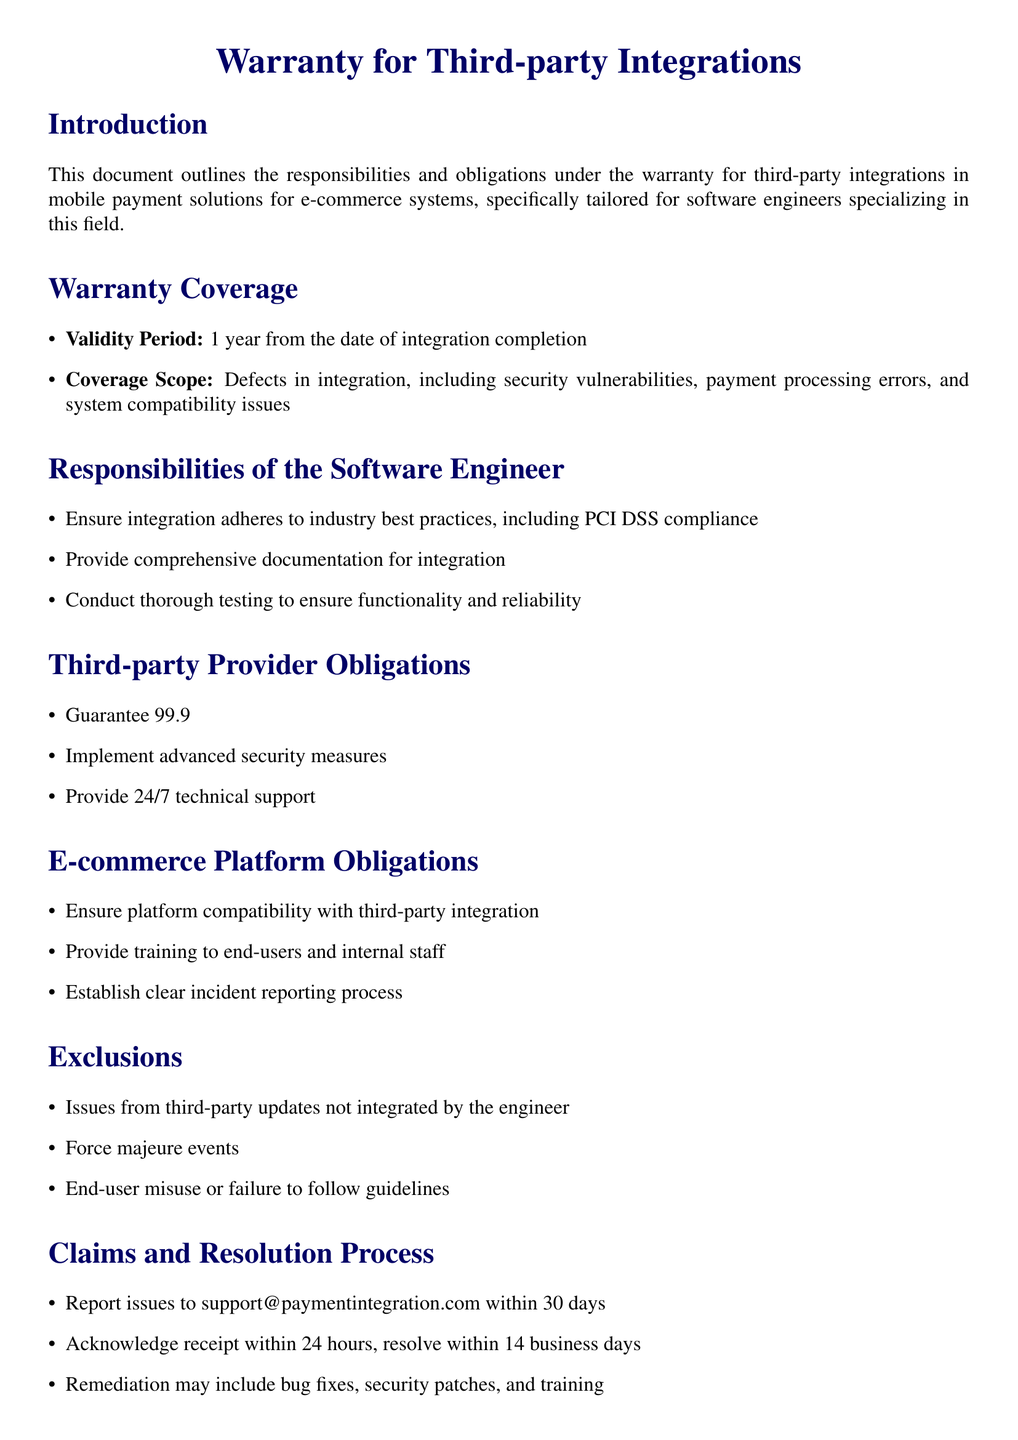What is the validity period of the warranty? The validity period is specified under warranty coverage, stating that it lasts 1 year from the date of integration completion.
Answer: 1 year What is the uptime guarantee provided by third-party providers? The document specifies that third-party providers must guarantee 99.9% uptime for payment processing services.
Answer: 99.9% What types of issues are excluded from warranty coverage? The document lists issues from third-party updates, force majeure events, and end-user misuse as exclusions.
Answer: Third-party updates, force majeure, end-user misuse How long does the support team have to acknowledge an issue report? The claims and resolution process outlines that the support team must acknowledge receipt of the report within 24 hours.
Answer: 24 hours What is the total financial liability cap mentioned in the document? The document states that the total financial liability is capped at fifty thousand dollars.
Answer: $50,000 What is one of the responsibilities of the software engineer? One of the responsibilities includes ensuring that the integration adheres to industry best practices, such as PCI DSS compliance.
Answer: PCI DSS compliance What must e-commerce platforms provide in relation to third-party integration? The document specifies that e-commerce platforms must ensure compatibility with third-party integration.
Answer: Compatibility What is included in the remediation process for claims? The remediation process may involve bug fixes, security patches, and training as part of resolving claims.
Answer: Bug fixes, security patches, training 